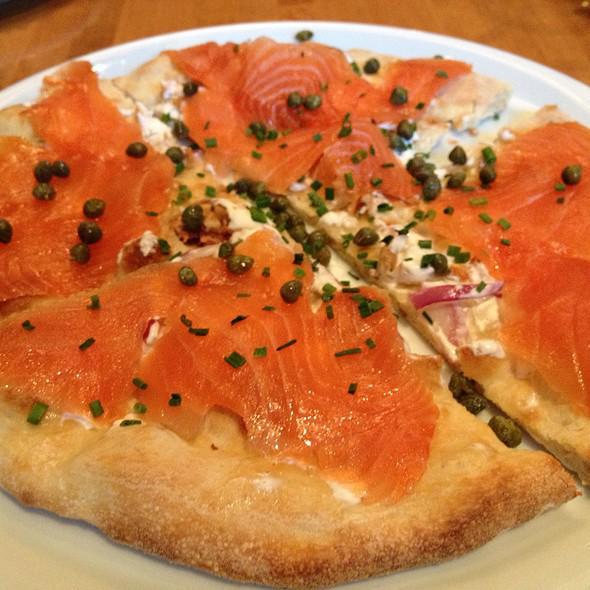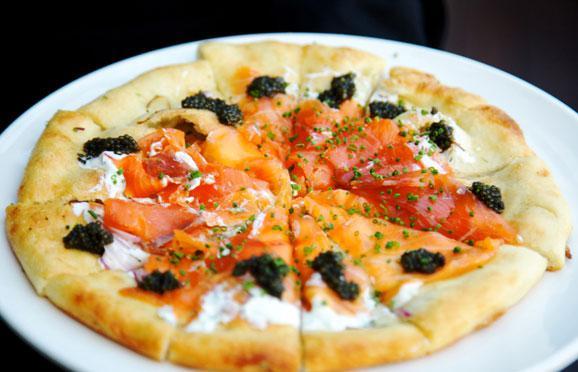The first image is the image on the left, the second image is the image on the right. Examine the images to the left and right. Is the description "In at least one image there is a salmon and carvery pizza with at least six slices." accurate? Answer yes or no. Yes. The first image is the image on the left, the second image is the image on the right. Assess this claim about the two images: "The right image features one round pizza cut into at least six wedge-shaped slices and garnished with black caviar.". Correct or not? Answer yes or no. Yes. 